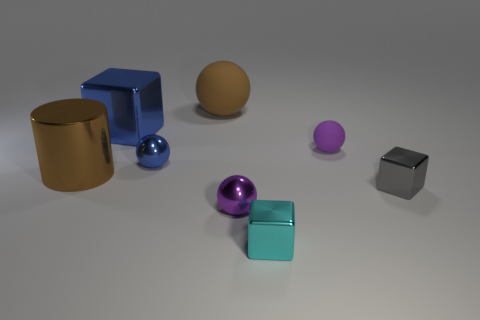Subtract all purple matte spheres. How many spheres are left? 3 Subtract all yellow cylinders. How many purple balls are left? 2 Add 1 large red blocks. How many objects exist? 9 Subtract all brown balls. How many balls are left? 3 Subtract all cubes. How many objects are left? 5 Add 6 blue metallic objects. How many blue metallic objects are left? 8 Add 6 large green matte things. How many large green matte things exist? 6 Subtract 1 purple spheres. How many objects are left? 7 Subtract all yellow balls. Subtract all brown cubes. How many balls are left? 4 Subtract all gray shiny blocks. Subtract all brown metallic objects. How many objects are left? 6 